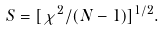<formula> <loc_0><loc_0><loc_500><loc_500>S = [ \chi ^ { 2 } / ( N - 1 ) ] ^ { 1 / 2 } .</formula> 